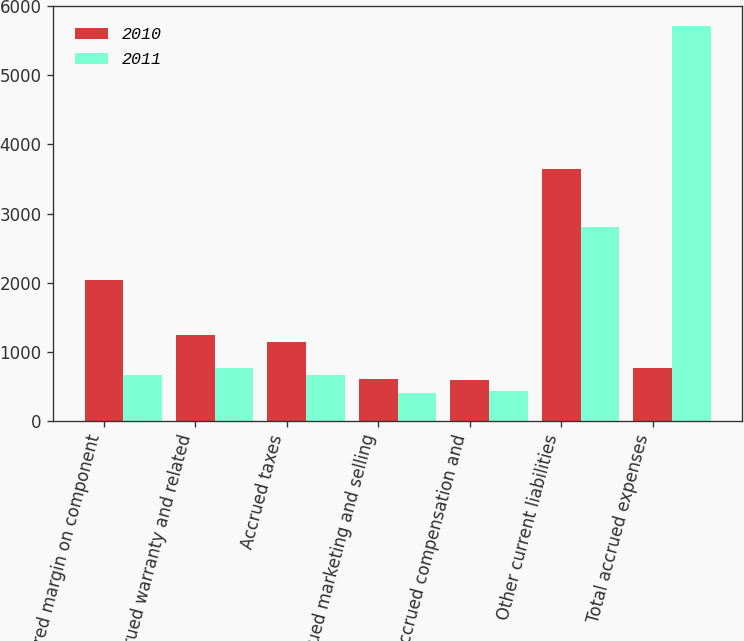Convert chart. <chart><loc_0><loc_0><loc_500><loc_500><stacked_bar_chart><ecel><fcel>Deferred margin on component<fcel>Accrued warranty and related<fcel>Accrued taxes<fcel>Accrued marketing and selling<fcel>Accrued compensation and<fcel>Other current liabilities<fcel>Total accrued expenses<nl><fcel>2010<fcel>2038<fcel>1240<fcel>1140<fcel>598<fcel>590<fcel>3641<fcel>761<nl><fcel>2011<fcel>663<fcel>761<fcel>658<fcel>396<fcel>436<fcel>2809<fcel>5723<nl></chart> 